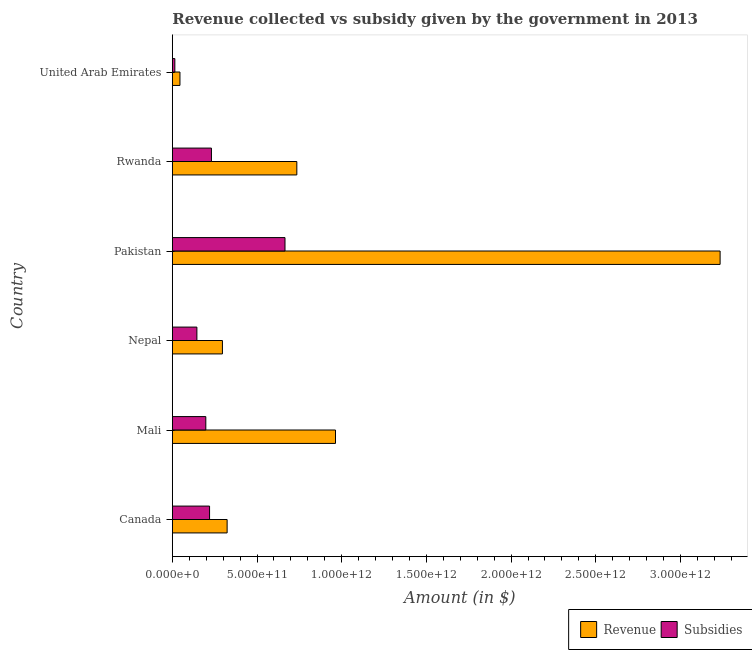Are the number of bars per tick equal to the number of legend labels?
Provide a succinct answer. Yes. Are the number of bars on each tick of the Y-axis equal?
Your answer should be compact. Yes. What is the label of the 5th group of bars from the top?
Offer a very short reply. Mali. What is the amount of subsidies given in United Arab Emirates?
Offer a terse response. 1.47e+1. Across all countries, what is the maximum amount of revenue collected?
Make the answer very short. 3.23e+12. Across all countries, what is the minimum amount of subsidies given?
Provide a short and direct response. 1.47e+1. In which country was the amount of revenue collected maximum?
Keep it short and to the point. Pakistan. In which country was the amount of subsidies given minimum?
Ensure brevity in your answer.  United Arab Emirates. What is the total amount of subsidies given in the graph?
Provide a succinct answer. 1.47e+12. What is the difference between the amount of revenue collected in Pakistan and that in United Arab Emirates?
Offer a very short reply. 3.19e+12. What is the difference between the amount of subsidies given in Pakistan and the amount of revenue collected in Canada?
Your answer should be very brief. 3.42e+11. What is the average amount of revenue collected per country?
Provide a succinct answer. 9.33e+11. What is the difference between the amount of subsidies given and amount of revenue collected in United Arab Emirates?
Keep it short and to the point. -3.02e+1. In how many countries, is the amount of subsidies given greater than 100000000000 $?
Offer a terse response. 5. Is the difference between the amount of subsidies given in Canada and Rwanda greater than the difference between the amount of revenue collected in Canada and Rwanda?
Your answer should be very brief. Yes. What is the difference between the highest and the second highest amount of revenue collected?
Your response must be concise. 2.27e+12. What is the difference between the highest and the lowest amount of subsidies given?
Keep it short and to the point. 6.50e+11. In how many countries, is the amount of subsidies given greater than the average amount of subsidies given taken over all countries?
Offer a very short reply. 1. Is the sum of the amount of subsidies given in Mali and Pakistan greater than the maximum amount of revenue collected across all countries?
Your response must be concise. No. What does the 2nd bar from the top in Pakistan represents?
Ensure brevity in your answer.  Revenue. What does the 2nd bar from the bottom in United Arab Emirates represents?
Your response must be concise. Subsidies. How many bars are there?
Keep it short and to the point. 12. Are all the bars in the graph horizontal?
Give a very brief answer. Yes. How many countries are there in the graph?
Offer a terse response. 6. What is the difference between two consecutive major ticks on the X-axis?
Provide a succinct answer. 5.00e+11. Does the graph contain grids?
Your answer should be very brief. No. Where does the legend appear in the graph?
Your response must be concise. Bottom right. How many legend labels are there?
Offer a very short reply. 2. What is the title of the graph?
Provide a succinct answer. Revenue collected vs subsidy given by the government in 2013. Does "Merchandise exports" appear as one of the legend labels in the graph?
Your answer should be compact. No. What is the label or title of the X-axis?
Give a very brief answer. Amount (in $). What is the label or title of the Y-axis?
Your answer should be compact. Country. What is the Amount (in $) in Revenue in Canada?
Offer a terse response. 3.23e+11. What is the Amount (in $) of Subsidies in Canada?
Ensure brevity in your answer.  2.20e+11. What is the Amount (in $) of Revenue in Mali?
Make the answer very short. 9.63e+11. What is the Amount (in $) of Subsidies in Mali?
Offer a terse response. 1.98e+11. What is the Amount (in $) of Revenue in Nepal?
Keep it short and to the point. 2.96e+11. What is the Amount (in $) of Subsidies in Nepal?
Offer a terse response. 1.45e+11. What is the Amount (in $) in Revenue in Pakistan?
Your answer should be very brief. 3.23e+12. What is the Amount (in $) in Subsidies in Pakistan?
Give a very brief answer. 6.65e+11. What is the Amount (in $) of Revenue in Rwanda?
Ensure brevity in your answer.  7.35e+11. What is the Amount (in $) in Subsidies in Rwanda?
Your response must be concise. 2.31e+11. What is the Amount (in $) in Revenue in United Arab Emirates?
Offer a very short reply. 4.49e+1. What is the Amount (in $) in Subsidies in United Arab Emirates?
Your answer should be compact. 1.47e+1. Across all countries, what is the maximum Amount (in $) of Revenue?
Make the answer very short. 3.23e+12. Across all countries, what is the maximum Amount (in $) of Subsidies?
Keep it short and to the point. 6.65e+11. Across all countries, what is the minimum Amount (in $) in Revenue?
Provide a short and direct response. 4.49e+1. Across all countries, what is the minimum Amount (in $) of Subsidies?
Give a very brief answer. 1.47e+1. What is the total Amount (in $) of Revenue in the graph?
Provide a short and direct response. 5.60e+12. What is the total Amount (in $) in Subsidies in the graph?
Your answer should be compact. 1.47e+12. What is the difference between the Amount (in $) in Revenue in Canada and that in Mali?
Offer a terse response. -6.40e+11. What is the difference between the Amount (in $) in Subsidies in Canada and that in Mali?
Offer a terse response. 2.21e+1. What is the difference between the Amount (in $) of Revenue in Canada and that in Nepal?
Your answer should be very brief. 2.78e+1. What is the difference between the Amount (in $) of Subsidies in Canada and that in Nepal?
Keep it short and to the point. 7.48e+1. What is the difference between the Amount (in $) of Revenue in Canada and that in Pakistan?
Your answer should be compact. -2.91e+12. What is the difference between the Amount (in $) in Subsidies in Canada and that in Pakistan?
Provide a short and direct response. -4.45e+11. What is the difference between the Amount (in $) in Revenue in Canada and that in Rwanda?
Give a very brief answer. -4.12e+11. What is the difference between the Amount (in $) in Subsidies in Canada and that in Rwanda?
Provide a succinct answer. -1.11e+1. What is the difference between the Amount (in $) of Revenue in Canada and that in United Arab Emirates?
Offer a very short reply. 2.78e+11. What is the difference between the Amount (in $) of Subsidies in Canada and that in United Arab Emirates?
Your response must be concise. 2.05e+11. What is the difference between the Amount (in $) of Revenue in Mali and that in Nepal?
Offer a terse response. 6.68e+11. What is the difference between the Amount (in $) in Subsidies in Mali and that in Nepal?
Ensure brevity in your answer.  5.27e+1. What is the difference between the Amount (in $) in Revenue in Mali and that in Pakistan?
Give a very brief answer. -2.27e+12. What is the difference between the Amount (in $) in Subsidies in Mali and that in Pakistan?
Provide a succinct answer. -4.67e+11. What is the difference between the Amount (in $) of Revenue in Mali and that in Rwanda?
Provide a succinct answer. 2.28e+11. What is the difference between the Amount (in $) of Subsidies in Mali and that in Rwanda?
Offer a terse response. -3.32e+1. What is the difference between the Amount (in $) of Revenue in Mali and that in United Arab Emirates?
Ensure brevity in your answer.  9.18e+11. What is the difference between the Amount (in $) of Subsidies in Mali and that in United Arab Emirates?
Offer a terse response. 1.83e+11. What is the difference between the Amount (in $) of Revenue in Nepal and that in Pakistan?
Your response must be concise. -2.94e+12. What is the difference between the Amount (in $) in Subsidies in Nepal and that in Pakistan?
Make the answer very short. -5.20e+11. What is the difference between the Amount (in $) of Revenue in Nepal and that in Rwanda?
Your answer should be compact. -4.39e+11. What is the difference between the Amount (in $) in Subsidies in Nepal and that in Rwanda?
Ensure brevity in your answer.  -8.59e+1. What is the difference between the Amount (in $) of Revenue in Nepal and that in United Arab Emirates?
Your answer should be compact. 2.51e+11. What is the difference between the Amount (in $) in Subsidies in Nepal and that in United Arab Emirates?
Your response must be concise. 1.30e+11. What is the difference between the Amount (in $) in Revenue in Pakistan and that in Rwanda?
Your answer should be compact. 2.50e+12. What is the difference between the Amount (in $) in Subsidies in Pakistan and that in Rwanda?
Your answer should be very brief. 4.34e+11. What is the difference between the Amount (in $) of Revenue in Pakistan and that in United Arab Emirates?
Offer a very short reply. 3.19e+12. What is the difference between the Amount (in $) in Subsidies in Pakistan and that in United Arab Emirates?
Make the answer very short. 6.50e+11. What is the difference between the Amount (in $) of Revenue in Rwanda and that in United Arab Emirates?
Your answer should be very brief. 6.90e+11. What is the difference between the Amount (in $) in Subsidies in Rwanda and that in United Arab Emirates?
Ensure brevity in your answer.  2.16e+11. What is the difference between the Amount (in $) in Revenue in Canada and the Amount (in $) in Subsidies in Mali?
Offer a very short reply. 1.26e+11. What is the difference between the Amount (in $) of Revenue in Canada and the Amount (in $) of Subsidies in Nepal?
Ensure brevity in your answer.  1.79e+11. What is the difference between the Amount (in $) in Revenue in Canada and the Amount (in $) in Subsidies in Pakistan?
Ensure brevity in your answer.  -3.42e+11. What is the difference between the Amount (in $) of Revenue in Canada and the Amount (in $) of Subsidies in Rwanda?
Keep it short and to the point. 9.26e+1. What is the difference between the Amount (in $) in Revenue in Canada and the Amount (in $) in Subsidies in United Arab Emirates?
Keep it short and to the point. 3.09e+11. What is the difference between the Amount (in $) in Revenue in Mali and the Amount (in $) in Subsidies in Nepal?
Provide a succinct answer. 8.18e+11. What is the difference between the Amount (in $) of Revenue in Mali and the Amount (in $) of Subsidies in Pakistan?
Offer a terse response. 2.98e+11. What is the difference between the Amount (in $) in Revenue in Mali and the Amount (in $) in Subsidies in Rwanda?
Offer a very short reply. 7.32e+11. What is the difference between the Amount (in $) of Revenue in Mali and the Amount (in $) of Subsidies in United Arab Emirates?
Make the answer very short. 9.49e+11. What is the difference between the Amount (in $) in Revenue in Nepal and the Amount (in $) in Subsidies in Pakistan?
Give a very brief answer. -3.69e+11. What is the difference between the Amount (in $) in Revenue in Nepal and the Amount (in $) in Subsidies in Rwanda?
Provide a succinct answer. 6.48e+1. What is the difference between the Amount (in $) of Revenue in Nepal and the Amount (in $) of Subsidies in United Arab Emirates?
Offer a very short reply. 2.81e+11. What is the difference between the Amount (in $) in Revenue in Pakistan and the Amount (in $) in Subsidies in Rwanda?
Ensure brevity in your answer.  3.00e+12. What is the difference between the Amount (in $) in Revenue in Pakistan and the Amount (in $) in Subsidies in United Arab Emirates?
Your answer should be compact. 3.22e+12. What is the difference between the Amount (in $) of Revenue in Rwanda and the Amount (in $) of Subsidies in United Arab Emirates?
Make the answer very short. 7.20e+11. What is the average Amount (in $) in Revenue per country?
Provide a short and direct response. 9.33e+11. What is the average Amount (in $) of Subsidies per country?
Your answer should be very brief. 2.45e+11. What is the difference between the Amount (in $) in Revenue and Amount (in $) in Subsidies in Canada?
Give a very brief answer. 1.04e+11. What is the difference between the Amount (in $) of Revenue and Amount (in $) of Subsidies in Mali?
Keep it short and to the point. 7.66e+11. What is the difference between the Amount (in $) of Revenue and Amount (in $) of Subsidies in Nepal?
Your answer should be compact. 1.51e+11. What is the difference between the Amount (in $) in Revenue and Amount (in $) in Subsidies in Pakistan?
Ensure brevity in your answer.  2.57e+12. What is the difference between the Amount (in $) in Revenue and Amount (in $) in Subsidies in Rwanda?
Give a very brief answer. 5.04e+11. What is the difference between the Amount (in $) of Revenue and Amount (in $) of Subsidies in United Arab Emirates?
Your answer should be very brief. 3.02e+1. What is the ratio of the Amount (in $) in Revenue in Canada to that in Mali?
Your answer should be very brief. 0.34. What is the ratio of the Amount (in $) in Subsidies in Canada to that in Mali?
Keep it short and to the point. 1.11. What is the ratio of the Amount (in $) of Revenue in Canada to that in Nepal?
Your answer should be compact. 1.09. What is the ratio of the Amount (in $) in Subsidies in Canada to that in Nepal?
Offer a very short reply. 1.52. What is the ratio of the Amount (in $) in Subsidies in Canada to that in Pakistan?
Your answer should be compact. 0.33. What is the ratio of the Amount (in $) of Revenue in Canada to that in Rwanda?
Offer a terse response. 0.44. What is the ratio of the Amount (in $) of Subsidies in Canada to that in Rwanda?
Your response must be concise. 0.95. What is the ratio of the Amount (in $) in Revenue in Canada to that in United Arab Emirates?
Offer a terse response. 7.2. What is the ratio of the Amount (in $) of Subsidies in Canada to that in United Arab Emirates?
Ensure brevity in your answer.  14.96. What is the ratio of the Amount (in $) of Revenue in Mali to that in Nepal?
Make the answer very short. 3.26. What is the ratio of the Amount (in $) of Subsidies in Mali to that in Nepal?
Your answer should be compact. 1.36. What is the ratio of the Amount (in $) of Revenue in Mali to that in Pakistan?
Offer a very short reply. 0.3. What is the ratio of the Amount (in $) in Subsidies in Mali to that in Pakistan?
Your response must be concise. 0.3. What is the ratio of the Amount (in $) in Revenue in Mali to that in Rwanda?
Offer a very short reply. 1.31. What is the ratio of the Amount (in $) of Subsidies in Mali to that in Rwanda?
Provide a succinct answer. 0.86. What is the ratio of the Amount (in $) of Revenue in Mali to that in United Arab Emirates?
Your answer should be very brief. 21.45. What is the ratio of the Amount (in $) in Subsidies in Mali to that in United Arab Emirates?
Your response must be concise. 13.45. What is the ratio of the Amount (in $) of Revenue in Nepal to that in Pakistan?
Offer a terse response. 0.09. What is the ratio of the Amount (in $) of Subsidies in Nepal to that in Pakistan?
Provide a short and direct response. 0.22. What is the ratio of the Amount (in $) in Revenue in Nepal to that in Rwanda?
Keep it short and to the point. 0.4. What is the ratio of the Amount (in $) in Subsidies in Nepal to that in Rwanda?
Keep it short and to the point. 0.63. What is the ratio of the Amount (in $) in Revenue in Nepal to that in United Arab Emirates?
Provide a short and direct response. 6.58. What is the ratio of the Amount (in $) in Subsidies in Nepal to that in United Arab Emirates?
Offer a terse response. 9.86. What is the ratio of the Amount (in $) of Revenue in Pakistan to that in Rwanda?
Provide a succinct answer. 4.4. What is the ratio of the Amount (in $) of Subsidies in Pakistan to that in Rwanda?
Provide a succinct answer. 2.88. What is the ratio of the Amount (in $) in Revenue in Pakistan to that in United Arab Emirates?
Offer a terse response. 72.01. What is the ratio of the Amount (in $) in Subsidies in Pakistan to that in United Arab Emirates?
Give a very brief answer. 45.28. What is the ratio of the Amount (in $) of Revenue in Rwanda to that in United Arab Emirates?
Your response must be concise. 16.36. What is the ratio of the Amount (in $) of Subsidies in Rwanda to that in United Arab Emirates?
Your answer should be compact. 15.71. What is the difference between the highest and the second highest Amount (in $) of Revenue?
Provide a short and direct response. 2.27e+12. What is the difference between the highest and the second highest Amount (in $) of Subsidies?
Make the answer very short. 4.34e+11. What is the difference between the highest and the lowest Amount (in $) in Revenue?
Provide a succinct answer. 3.19e+12. What is the difference between the highest and the lowest Amount (in $) of Subsidies?
Keep it short and to the point. 6.50e+11. 